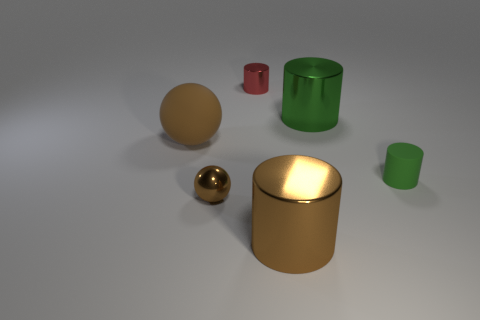There is a shiny object that is the same color as the tiny sphere; what is its shape?
Make the answer very short. Cylinder. There is a metal cylinder in front of the big green metallic thing; is its color the same as the metal ball that is behind the brown shiny cylinder?
Your answer should be very brief. Yes. There is another cylinder that is the same color as the rubber cylinder; what is its size?
Ensure brevity in your answer.  Large. Is the material of the small thing that is to the right of the red object the same as the small brown sphere?
Give a very brief answer. No. What number of other objects are the same shape as the brown matte object?
Ensure brevity in your answer.  1. What number of small brown objects are to the left of the ball behind the metal object that is left of the red metal cylinder?
Your answer should be compact. 0. What color is the large metallic cylinder that is in front of the green matte cylinder?
Give a very brief answer. Brown. There is a small metal thing that is in front of the matte sphere; is it the same color as the big sphere?
Provide a succinct answer. Yes. There is a brown thing that is the same shape as the red thing; what is its size?
Provide a succinct answer. Large. The big brown thing to the left of the large metallic cylinder that is in front of the small shiny thing in front of the brown rubber object is made of what material?
Give a very brief answer. Rubber. 